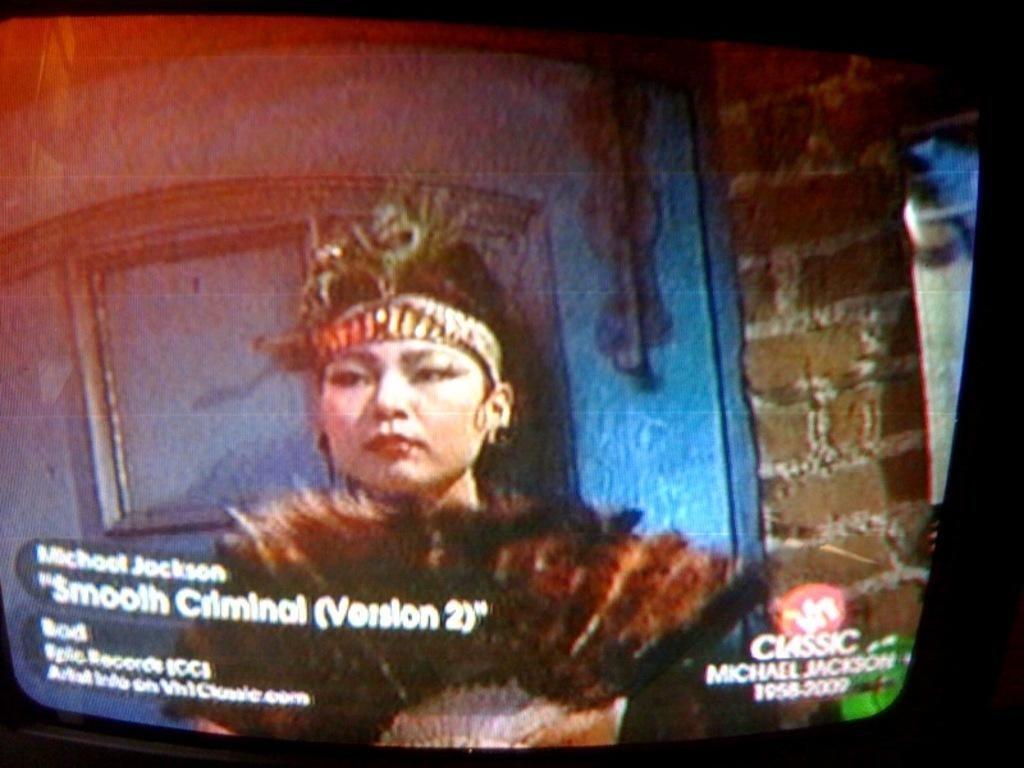What is the main object in the image? There is a screen in the image. What can be seen on the screen? A person is visible on the screen. What architectural feature is present in the image? There is a window in the image. What is the color of the wall in the image? The wall is brown in color. What type of board is being used to process the person's wishes in the image? There is no board or mention of wishes being processed in the image. 